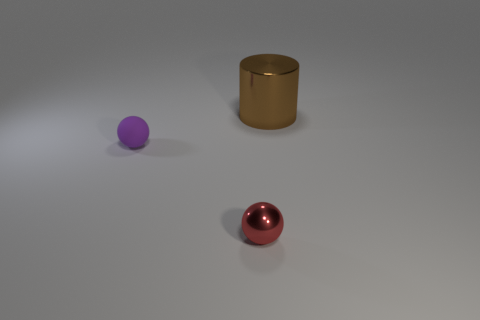Can you tell me about the lighting in this scene? The lighting in this scene appears to be soft and diffused, with few harsh shadows, indicating that the light source might be large or there may be several light sources. The way the objects are gently illuminated suggests that the environment is evenly lit, possibly simulating an overcast day or a studio setup with multiple lights designed to reduce shadow intensity. 